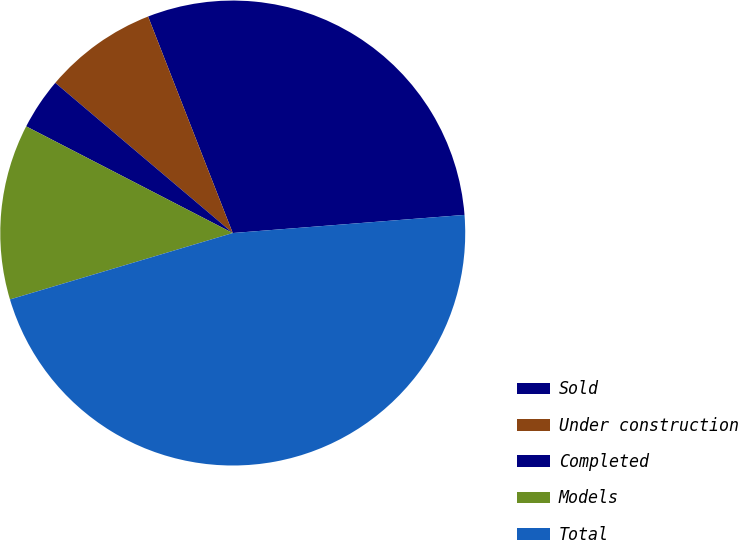Convert chart. <chart><loc_0><loc_0><loc_500><loc_500><pie_chart><fcel>Sold<fcel>Under construction<fcel>Completed<fcel>Models<fcel>Total<nl><fcel>29.69%<fcel>7.89%<fcel>3.59%<fcel>12.2%<fcel>46.63%<nl></chart> 